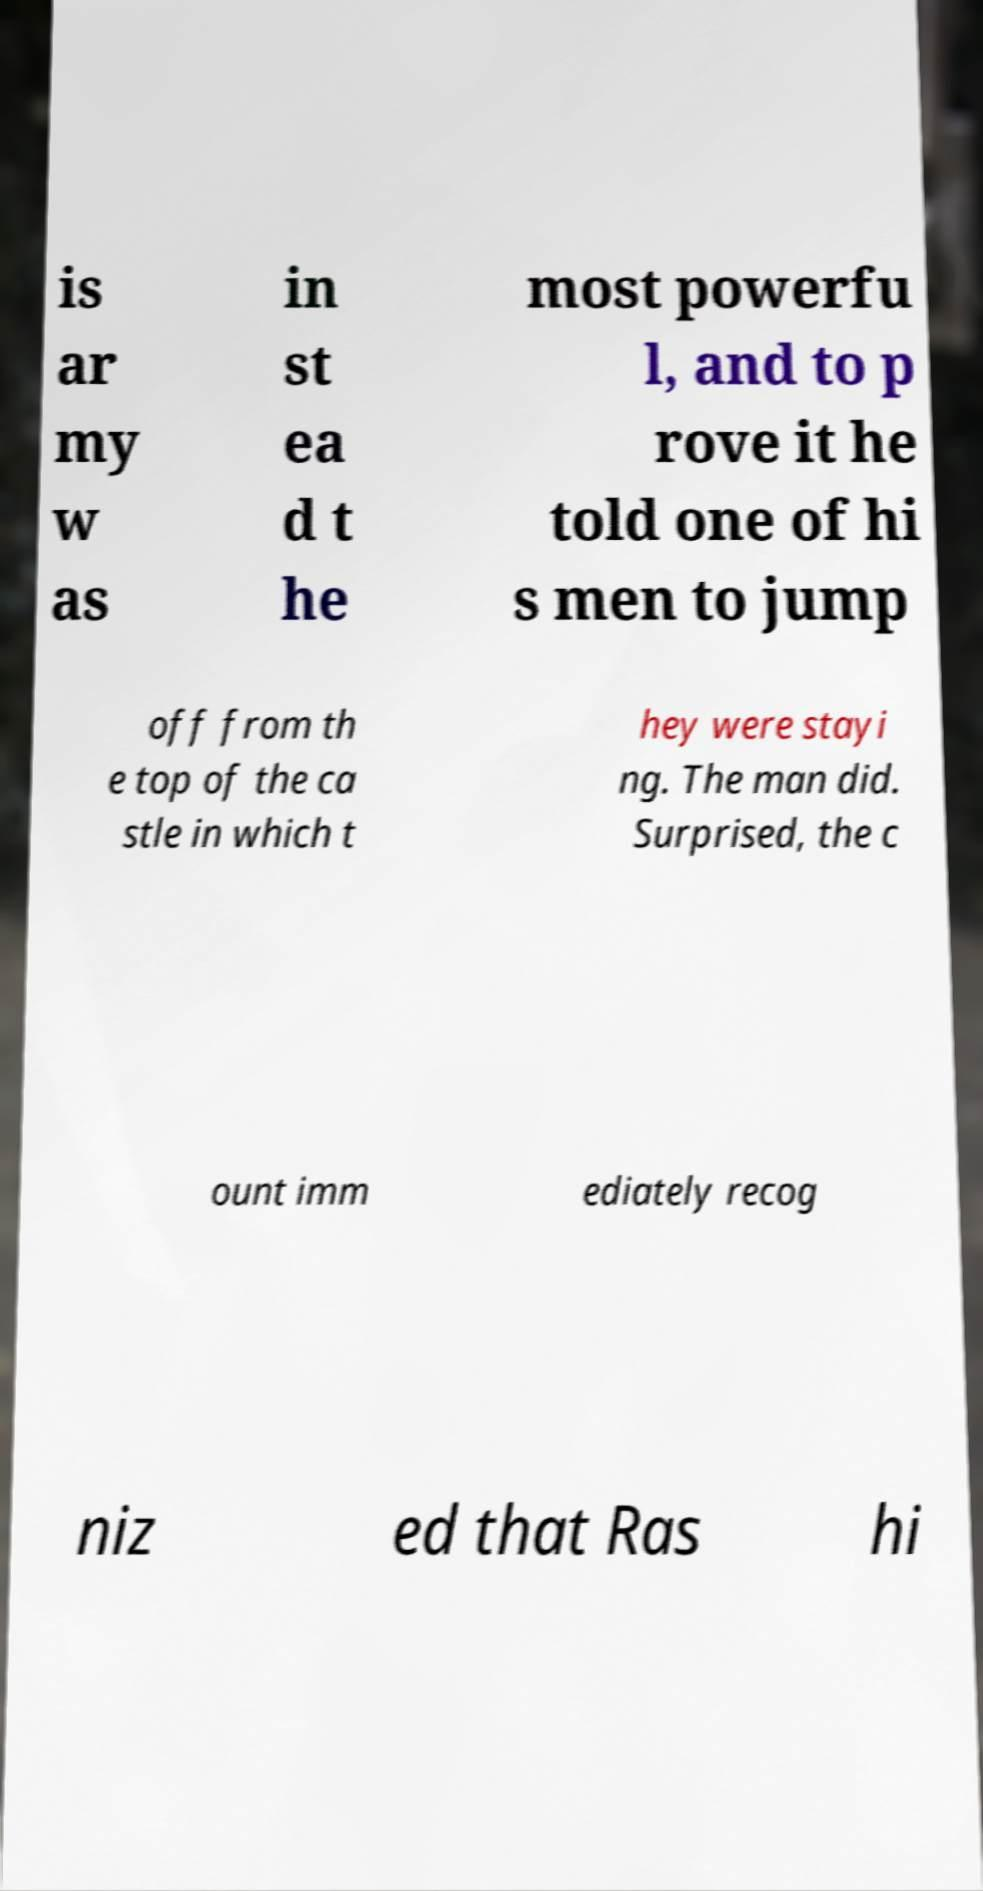Could you extract and type out the text from this image? is ar my w as in st ea d t he most powerfu l, and to p rove it he told one of hi s men to jump off from th e top of the ca stle in which t hey were stayi ng. The man did. Surprised, the c ount imm ediately recog niz ed that Ras hi 